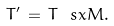<formula> <loc_0><loc_0><loc_500><loc_500>T ^ { \prime } \, = \, T \, \ s x { M } .</formula> 